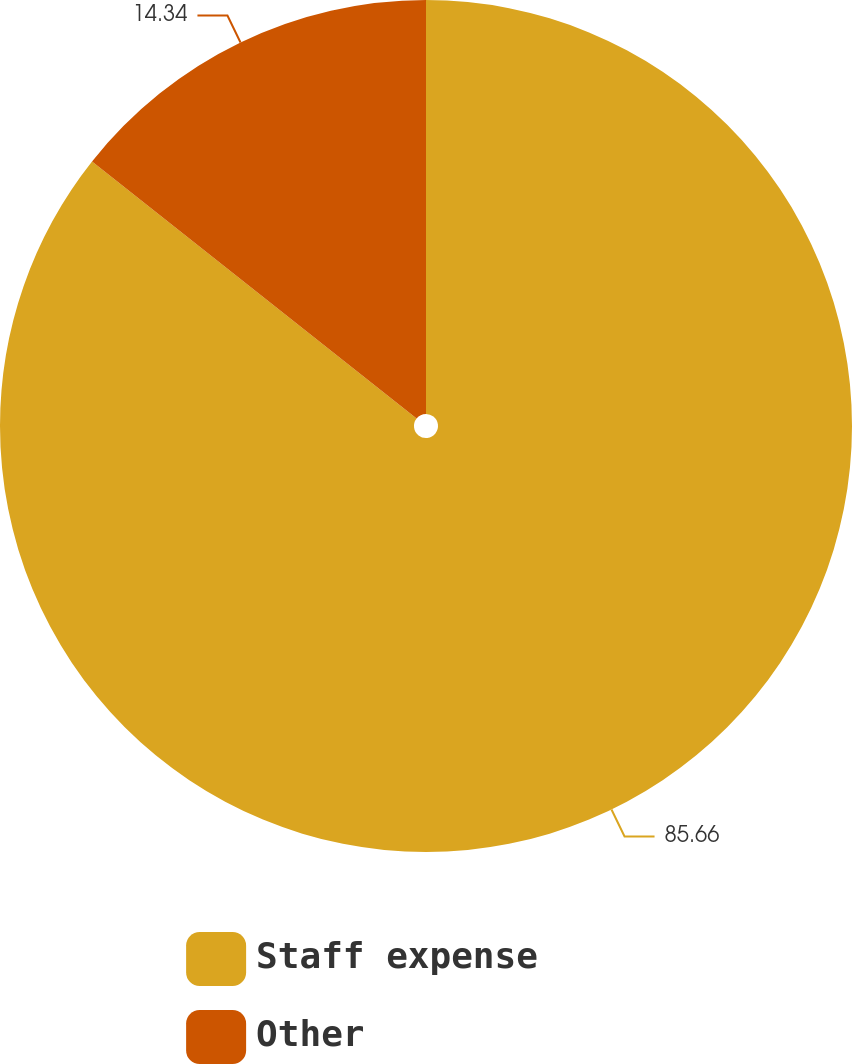Convert chart to OTSL. <chart><loc_0><loc_0><loc_500><loc_500><pie_chart><fcel>Staff expense<fcel>Other<nl><fcel>85.66%<fcel>14.34%<nl></chart> 